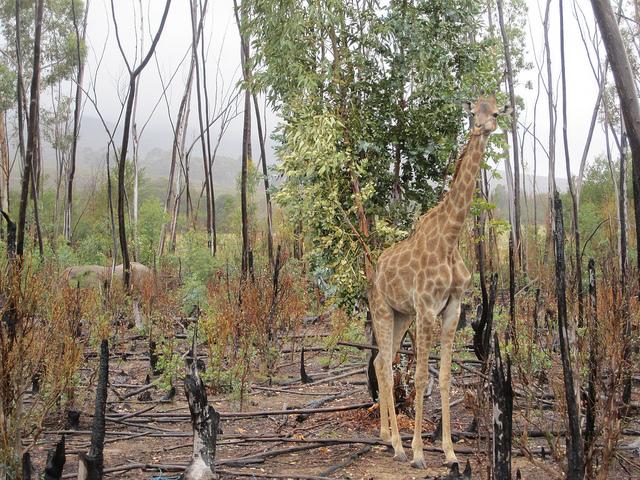What animal is in the picture?
Answer briefly. Giraffe. What is the weather like?
Be succinct. Cloudy. Is there another animal besides the giraffe?
Short answer required. Yes. Is the animal in the wild?
Give a very brief answer. Yes. How many giraffes are there?
Answer briefly. 1. Is the giraffe standing near a forest?
Be succinct. Yes. Does the animal look like he needs a haircut?
Give a very brief answer. No. 